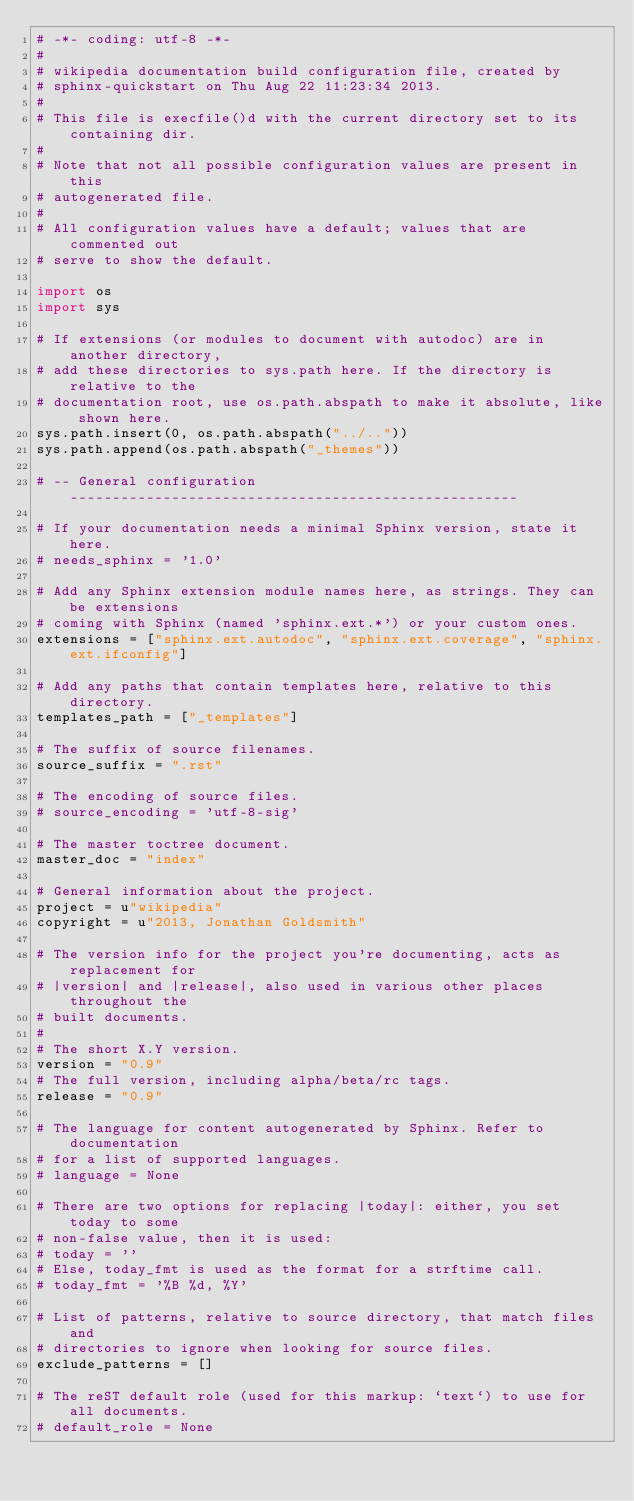<code> <loc_0><loc_0><loc_500><loc_500><_Python_># -*- coding: utf-8 -*-
#
# wikipedia documentation build configuration file, created by
# sphinx-quickstart on Thu Aug 22 11:23:34 2013.
#
# This file is execfile()d with the current directory set to its containing dir.
#
# Note that not all possible configuration values are present in this
# autogenerated file.
#
# All configuration values have a default; values that are commented out
# serve to show the default.

import os
import sys

# If extensions (or modules to document with autodoc) are in another directory,
# add these directories to sys.path here. If the directory is relative to the
# documentation root, use os.path.abspath to make it absolute, like shown here.
sys.path.insert(0, os.path.abspath("../.."))
sys.path.append(os.path.abspath("_themes"))

# -- General configuration -----------------------------------------------------

# If your documentation needs a minimal Sphinx version, state it here.
# needs_sphinx = '1.0'

# Add any Sphinx extension module names here, as strings. They can be extensions
# coming with Sphinx (named 'sphinx.ext.*') or your custom ones.
extensions = ["sphinx.ext.autodoc", "sphinx.ext.coverage", "sphinx.ext.ifconfig"]

# Add any paths that contain templates here, relative to this directory.
templates_path = ["_templates"]

# The suffix of source filenames.
source_suffix = ".rst"

# The encoding of source files.
# source_encoding = 'utf-8-sig'

# The master toctree document.
master_doc = "index"

# General information about the project.
project = u"wikipedia"
copyright = u"2013, Jonathan Goldsmith"

# The version info for the project you're documenting, acts as replacement for
# |version| and |release|, also used in various other places throughout the
# built documents.
#
# The short X.Y version.
version = "0.9"
# The full version, including alpha/beta/rc tags.
release = "0.9"

# The language for content autogenerated by Sphinx. Refer to documentation
# for a list of supported languages.
# language = None

# There are two options for replacing |today|: either, you set today to some
# non-false value, then it is used:
# today = ''
# Else, today_fmt is used as the format for a strftime call.
# today_fmt = '%B %d, %Y'

# List of patterns, relative to source directory, that match files and
# directories to ignore when looking for source files.
exclude_patterns = []

# The reST default role (used for this markup: `text`) to use for all documents.
# default_role = None
</code> 